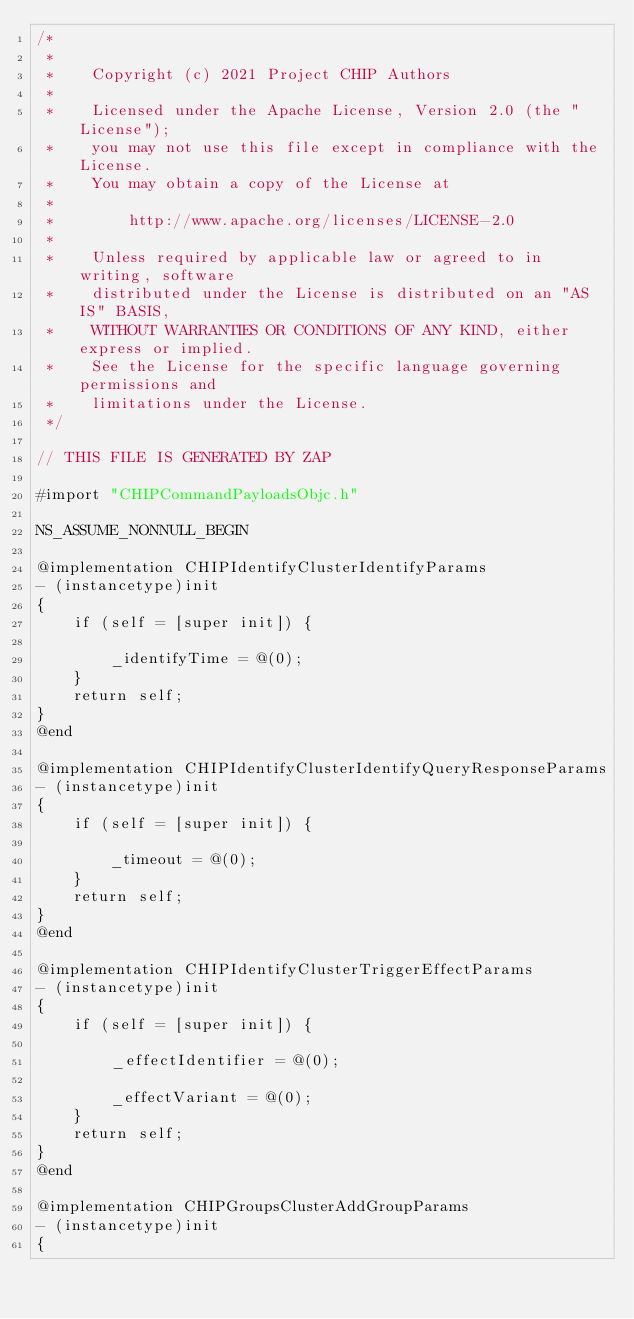<code> <loc_0><loc_0><loc_500><loc_500><_ObjectiveC_>/*
 *
 *    Copyright (c) 2021 Project CHIP Authors
 *
 *    Licensed under the Apache License, Version 2.0 (the "License");
 *    you may not use this file except in compliance with the License.
 *    You may obtain a copy of the License at
 *
 *        http://www.apache.org/licenses/LICENSE-2.0
 *
 *    Unless required by applicable law or agreed to in writing, software
 *    distributed under the License is distributed on an "AS IS" BASIS,
 *    WITHOUT WARRANTIES OR CONDITIONS OF ANY KIND, either express or implied.
 *    See the License for the specific language governing permissions and
 *    limitations under the License.
 */

// THIS FILE IS GENERATED BY ZAP

#import "CHIPCommandPayloadsObjc.h"

NS_ASSUME_NONNULL_BEGIN

@implementation CHIPIdentifyClusterIdentifyParams
- (instancetype)init
{
    if (self = [super init]) {

        _identifyTime = @(0);
    }
    return self;
}
@end

@implementation CHIPIdentifyClusterIdentifyQueryResponseParams
- (instancetype)init
{
    if (self = [super init]) {

        _timeout = @(0);
    }
    return self;
}
@end

@implementation CHIPIdentifyClusterTriggerEffectParams
- (instancetype)init
{
    if (self = [super init]) {

        _effectIdentifier = @(0);

        _effectVariant = @(0);
    }
    return self;
}
@end

@implementation CHIPGroupsClusterAddGroupParams
- (instancetype)init
{</code> 